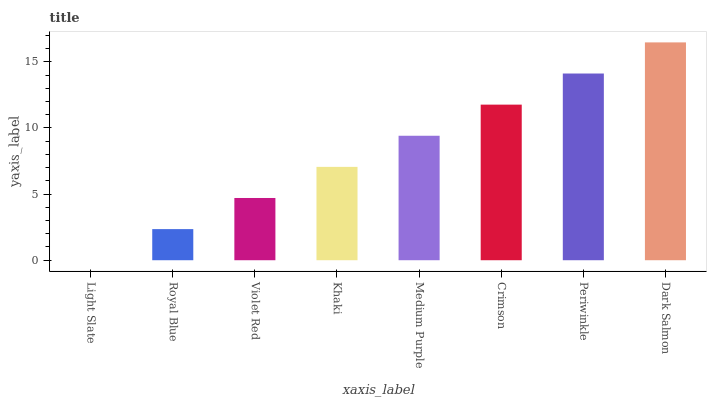Is Light Slate the minimum?
Answer yes or no. Yes. Is Dark Salmon the maximum?
Answer yes or no. Yes. Is Royal Blue the minimum?
Answer yes or no. No. Is Royal Blue the maximum?
Answer yes or no. No. Is Royal Blue greater than Light Slate?
Answer yes or no. Yes. Is Light Slate less than Royal Blue?
Answer yes or no. Yes. Is Light Slate greater than Royal Blue?
Answer yes or no. No. Is Royal Blue less than Light Slate?
Answer yes or no. No. Is Medium Purple the high median?
Answer yes or no. Yes. Is Khaki the low median?
Answer yes or no. Yes. Is Crimson the high median?
Answer yes or no. No. Is Periwinkle the low median?
Answer yes or no. No. 